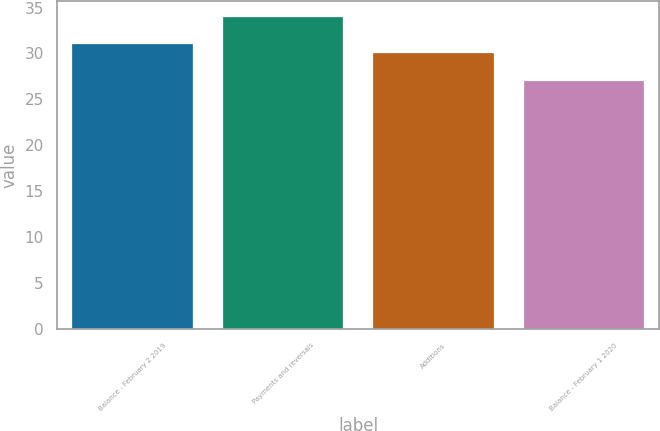<chart> <loc_0><loc_0><loc_500><loc_500><bar_chart><fcel>Balance - February 2 2019<fcel>Payments and reversals<fcel>Additions<fcel>Balance - February 1 2020<nl><fcel>31<fcel>34<fcel>30<fcel>27<nl></chart> 